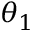<formula> <loc_0><loc_0><loc_500><loc_500>\theta _ { 1 }</formula> 